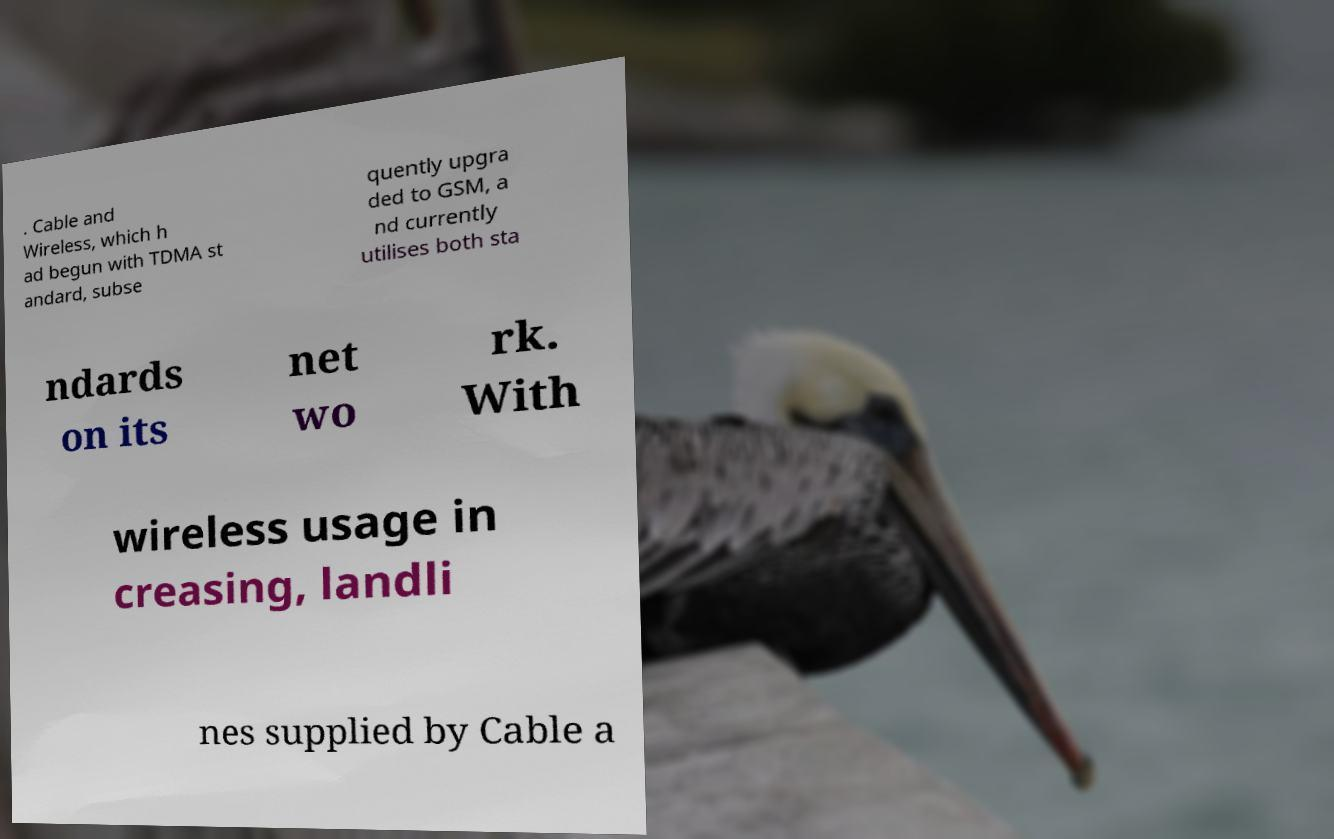Can you read and provide the text displayed in the image?This photo seems to have some interesting text. Can you extract and type it out for me? . Cable and Wireless, which h ad begun with TDMA st andard, subse quently upgra ded to GSM, a nd currently utilises both sta ndards on its net wo rk. With wireless usage in creasing, landli nes supplied by Cable a 